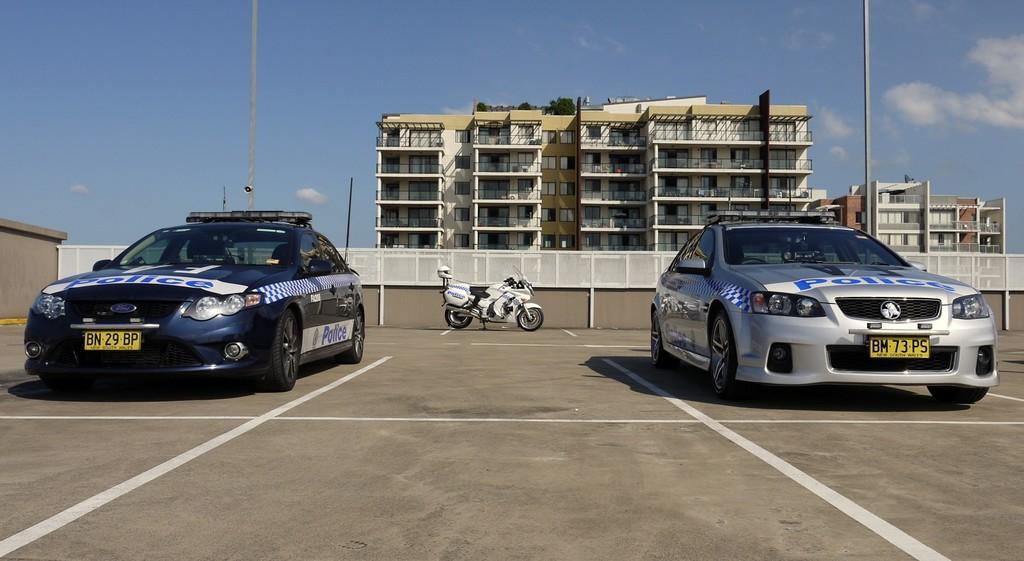Can you describe this image briefly? In this image we can see cars and bike on the road, fence, poles, wall and security camera. In the background there are buildings, windows, plants and clouds in the sky. 